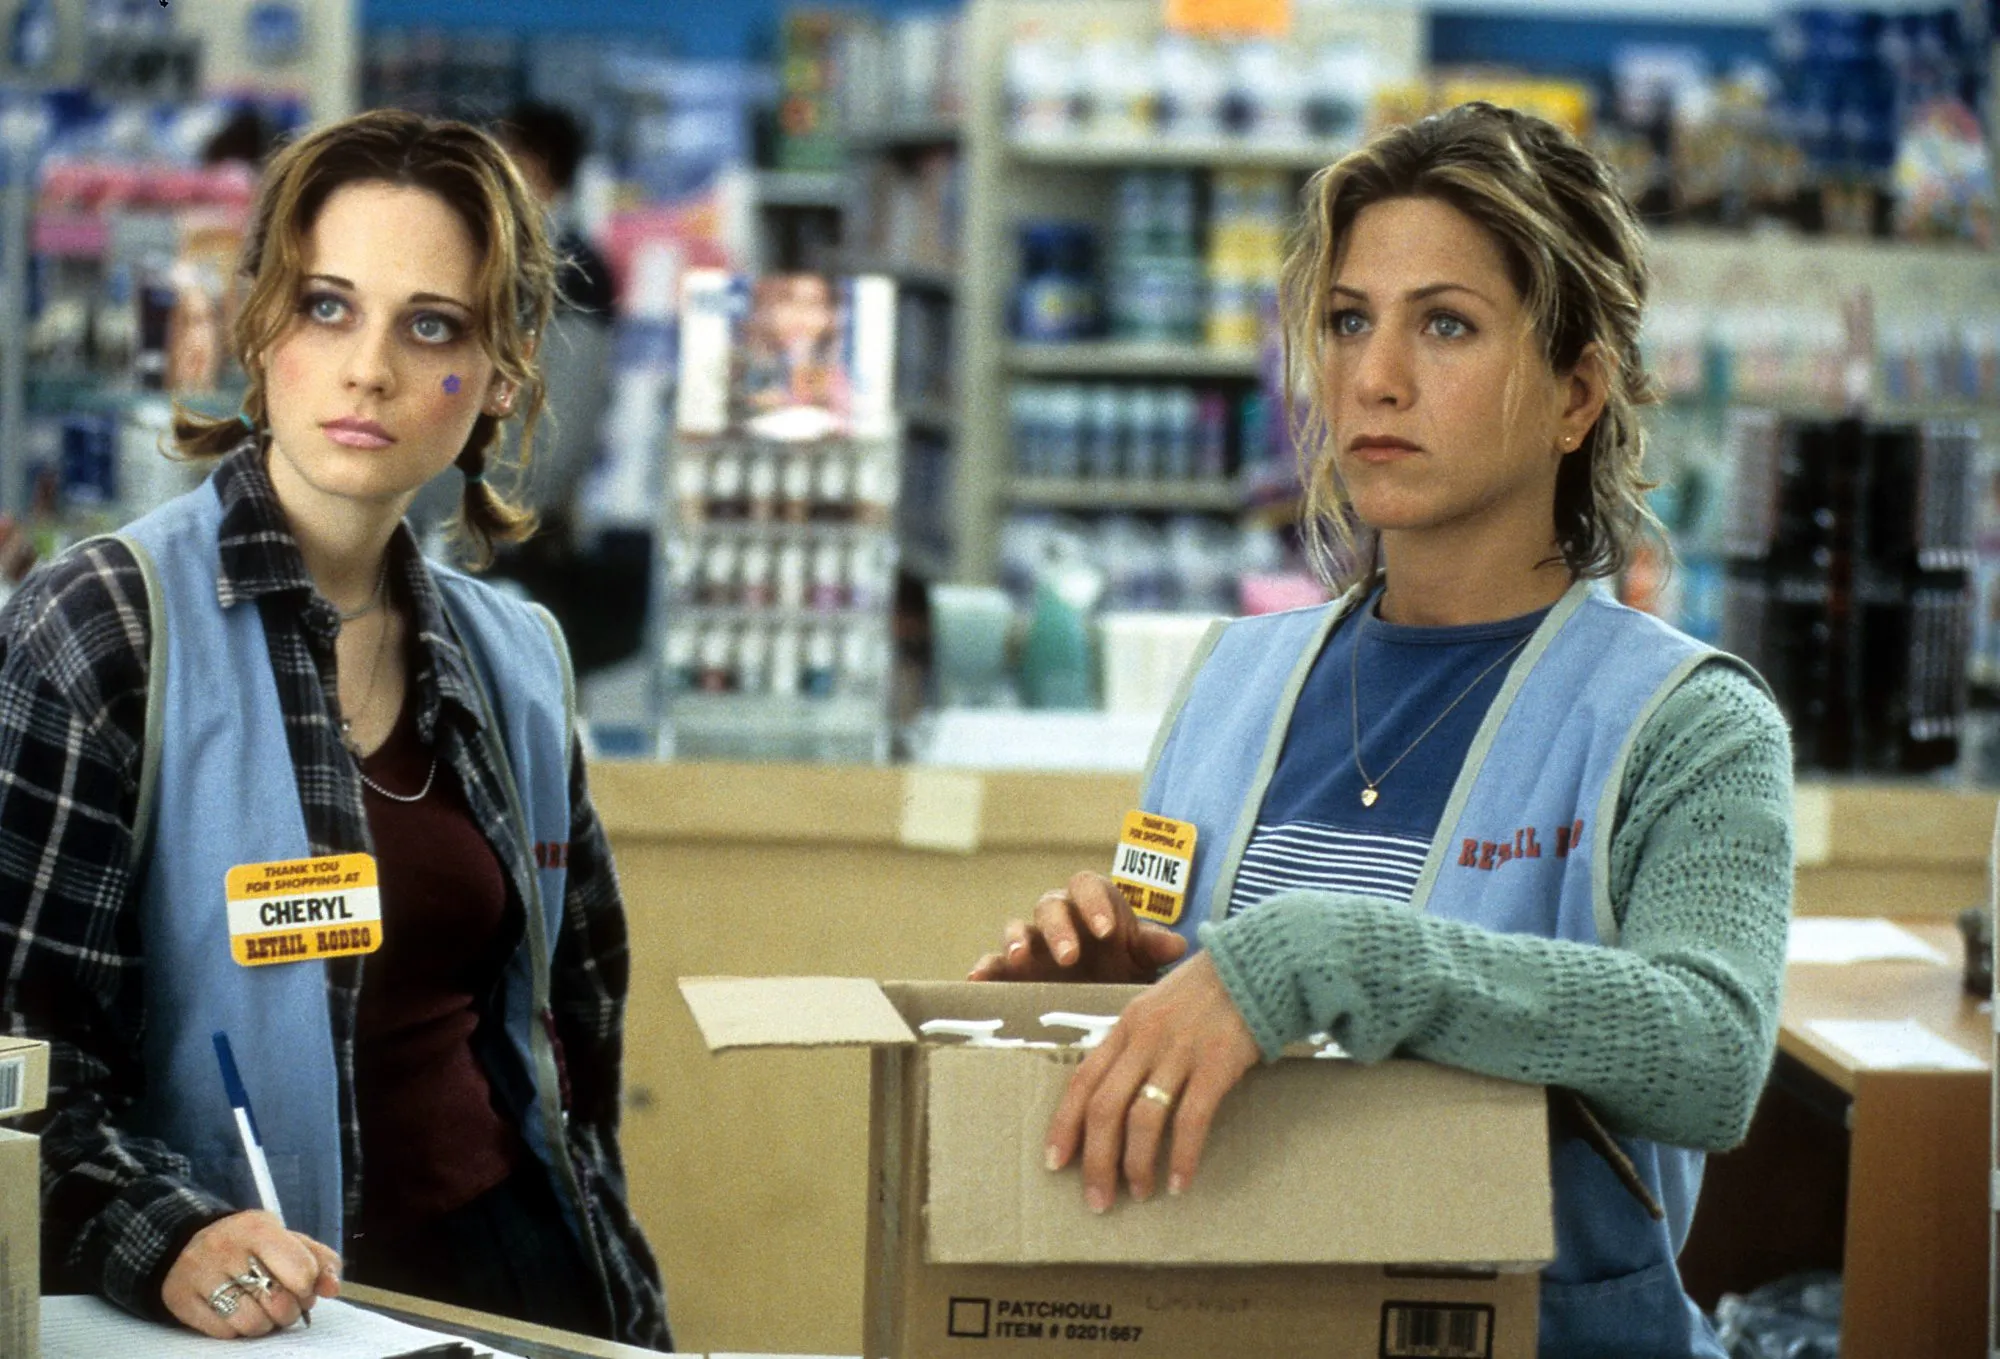What do you think Cheryl and Justine are thinking about? Cheryl and Justine both seem to be reacting to something happening just out of the frame. Their concerned expressions suggest they might be witnessing an unexpected event or hearing some troubling news. Cheryl might be trying to figure out the best course of action while keeping her composure, whereas Justine appears to be slightly more anxious, perhaps considering the implications of what they are witnessing for their jobs or personal lives. If these characters could have an unusual adventure, what would it be? Imagine Cheryl and Justine finding a hidden trapdoor in the stockroom that leads to an alternate universe where the store is a magical emporium. In this world, everyday items have mystical properties, and the duo must navigate a series of whimsical and perilous challenges to find a key ingredient that will save their real-world store from closure caused by a mysterious curse. 